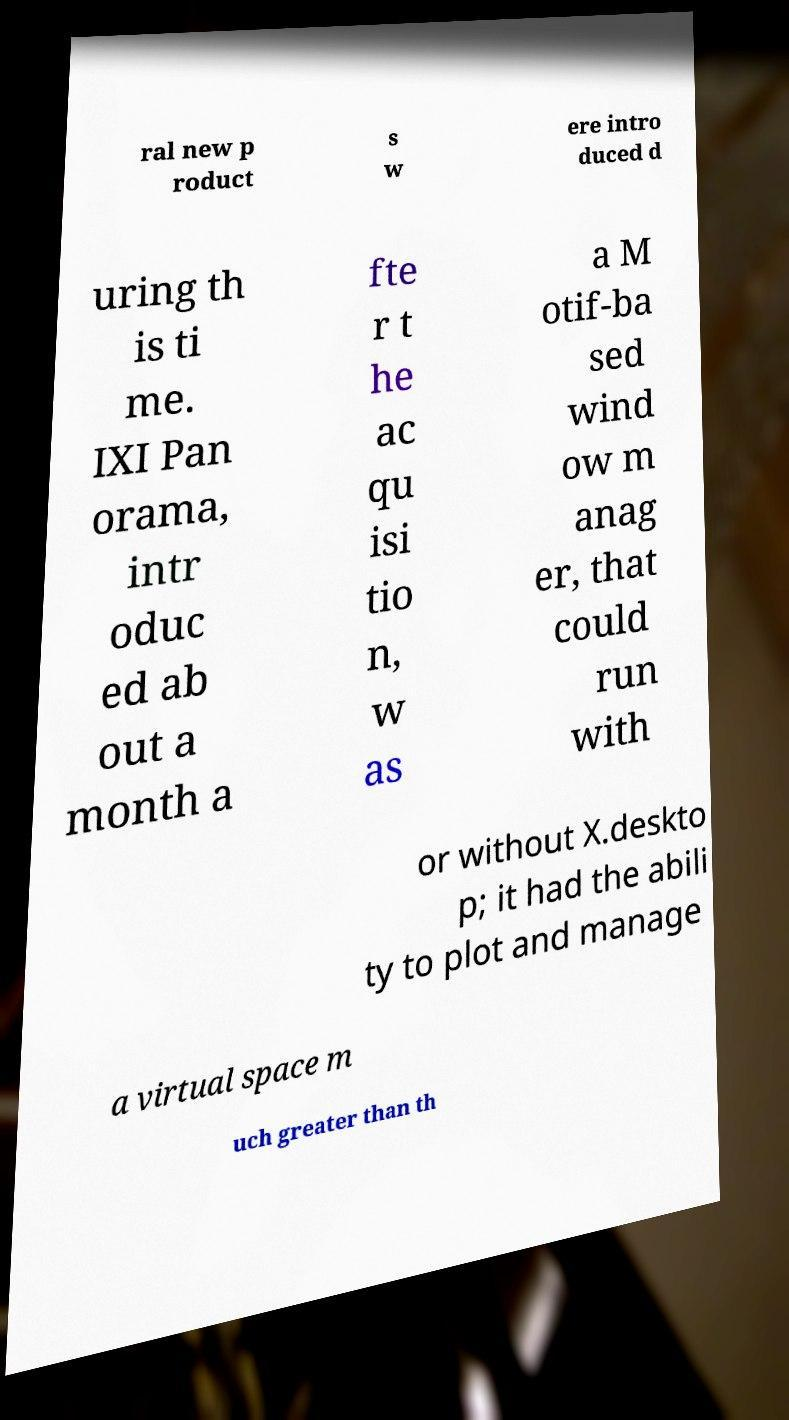There's text embedded in this image that I need extracted. Can you transcribe it verbatim? ral new p roduct s w ere intro duced d uring th is ti me. IXI Pan orama, intr oduc ed ab out a month a fte r t he ac qu isi tio n, w as a M otif-ba sed wind ow m anag er, that could run with or without X.deskto p; it had the abili ty to plot and manage a virtual space m uch greater than th 